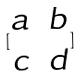<formula> <loc_0><loc_0><loc_500><loc_500>[ \begin{matrix} a & b \\ c & d \\ \end{matrix} ]</formula> 